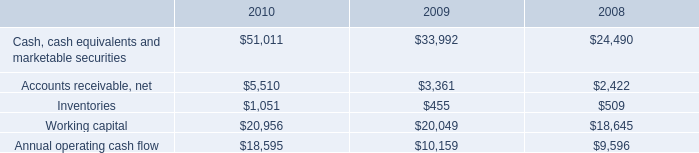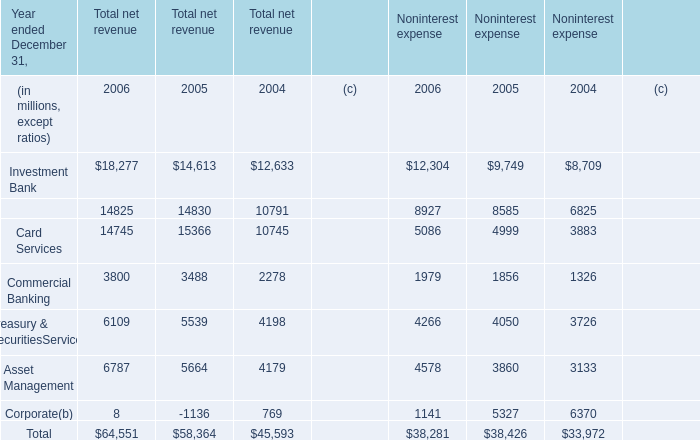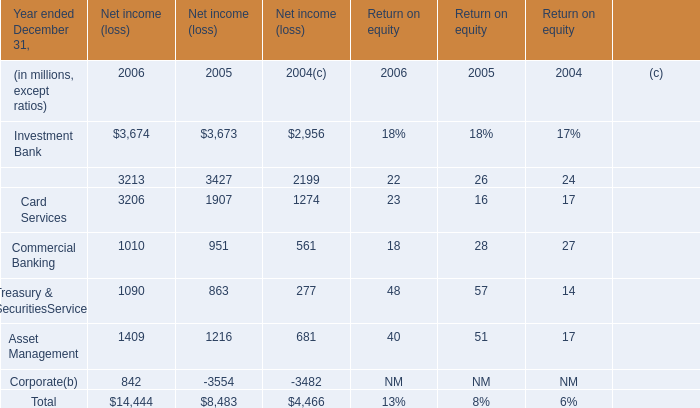In which year is Investment Bank positive for Net income (loss)? 
Answer: 2004 2005 2006. 